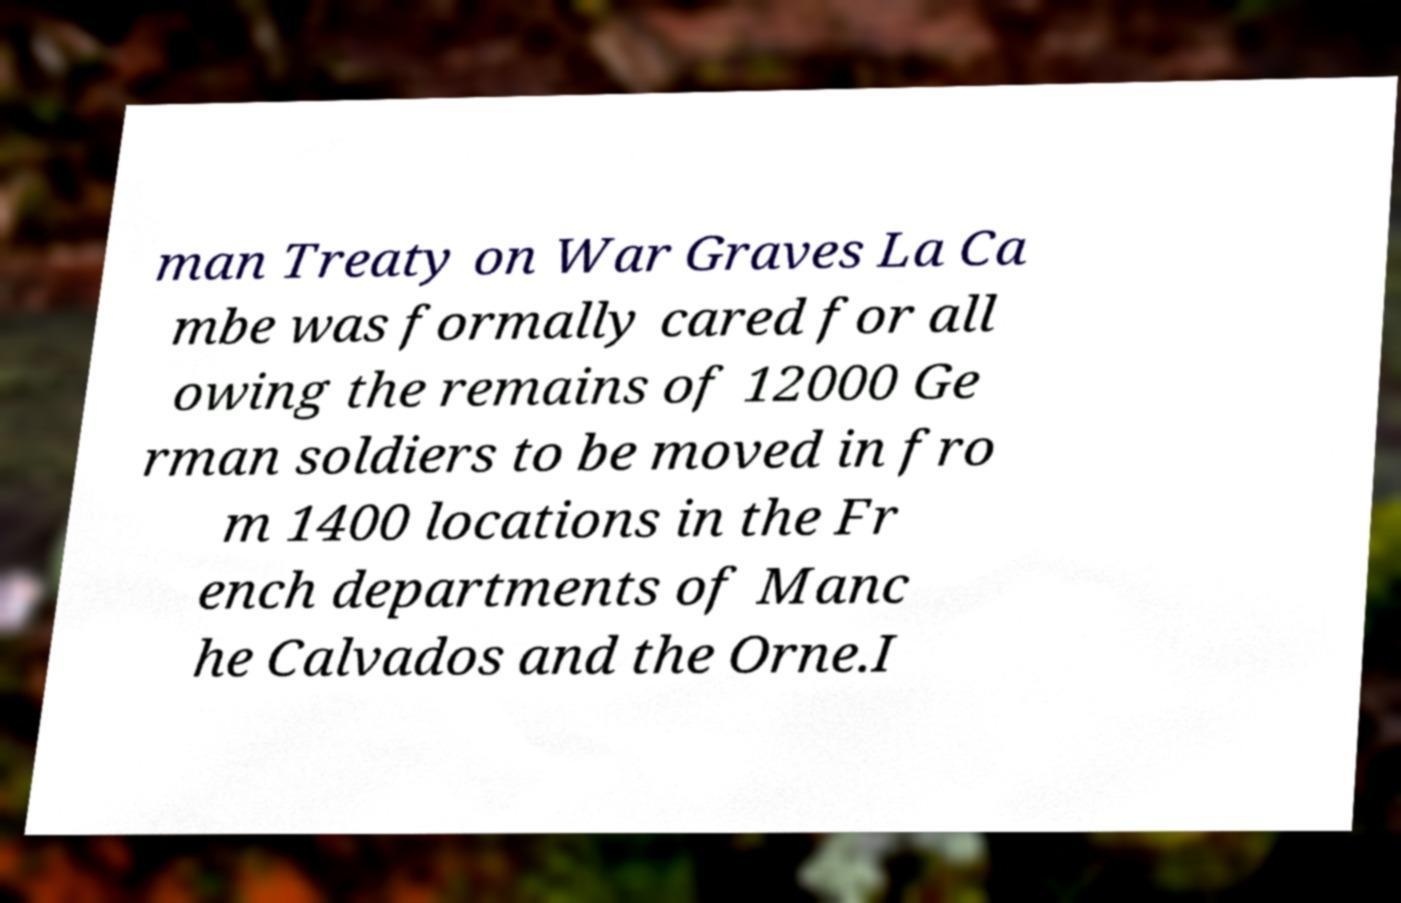Please read and relay the text visible in this image. What does it say? man Treaty on War Graves La Ca mbe was formally cared for all owing the remains of 12000 Ge rman soldiers to be moved in fro m 1400 locations in the Fr ench departments of Manc he Calvados and the Orne.I 